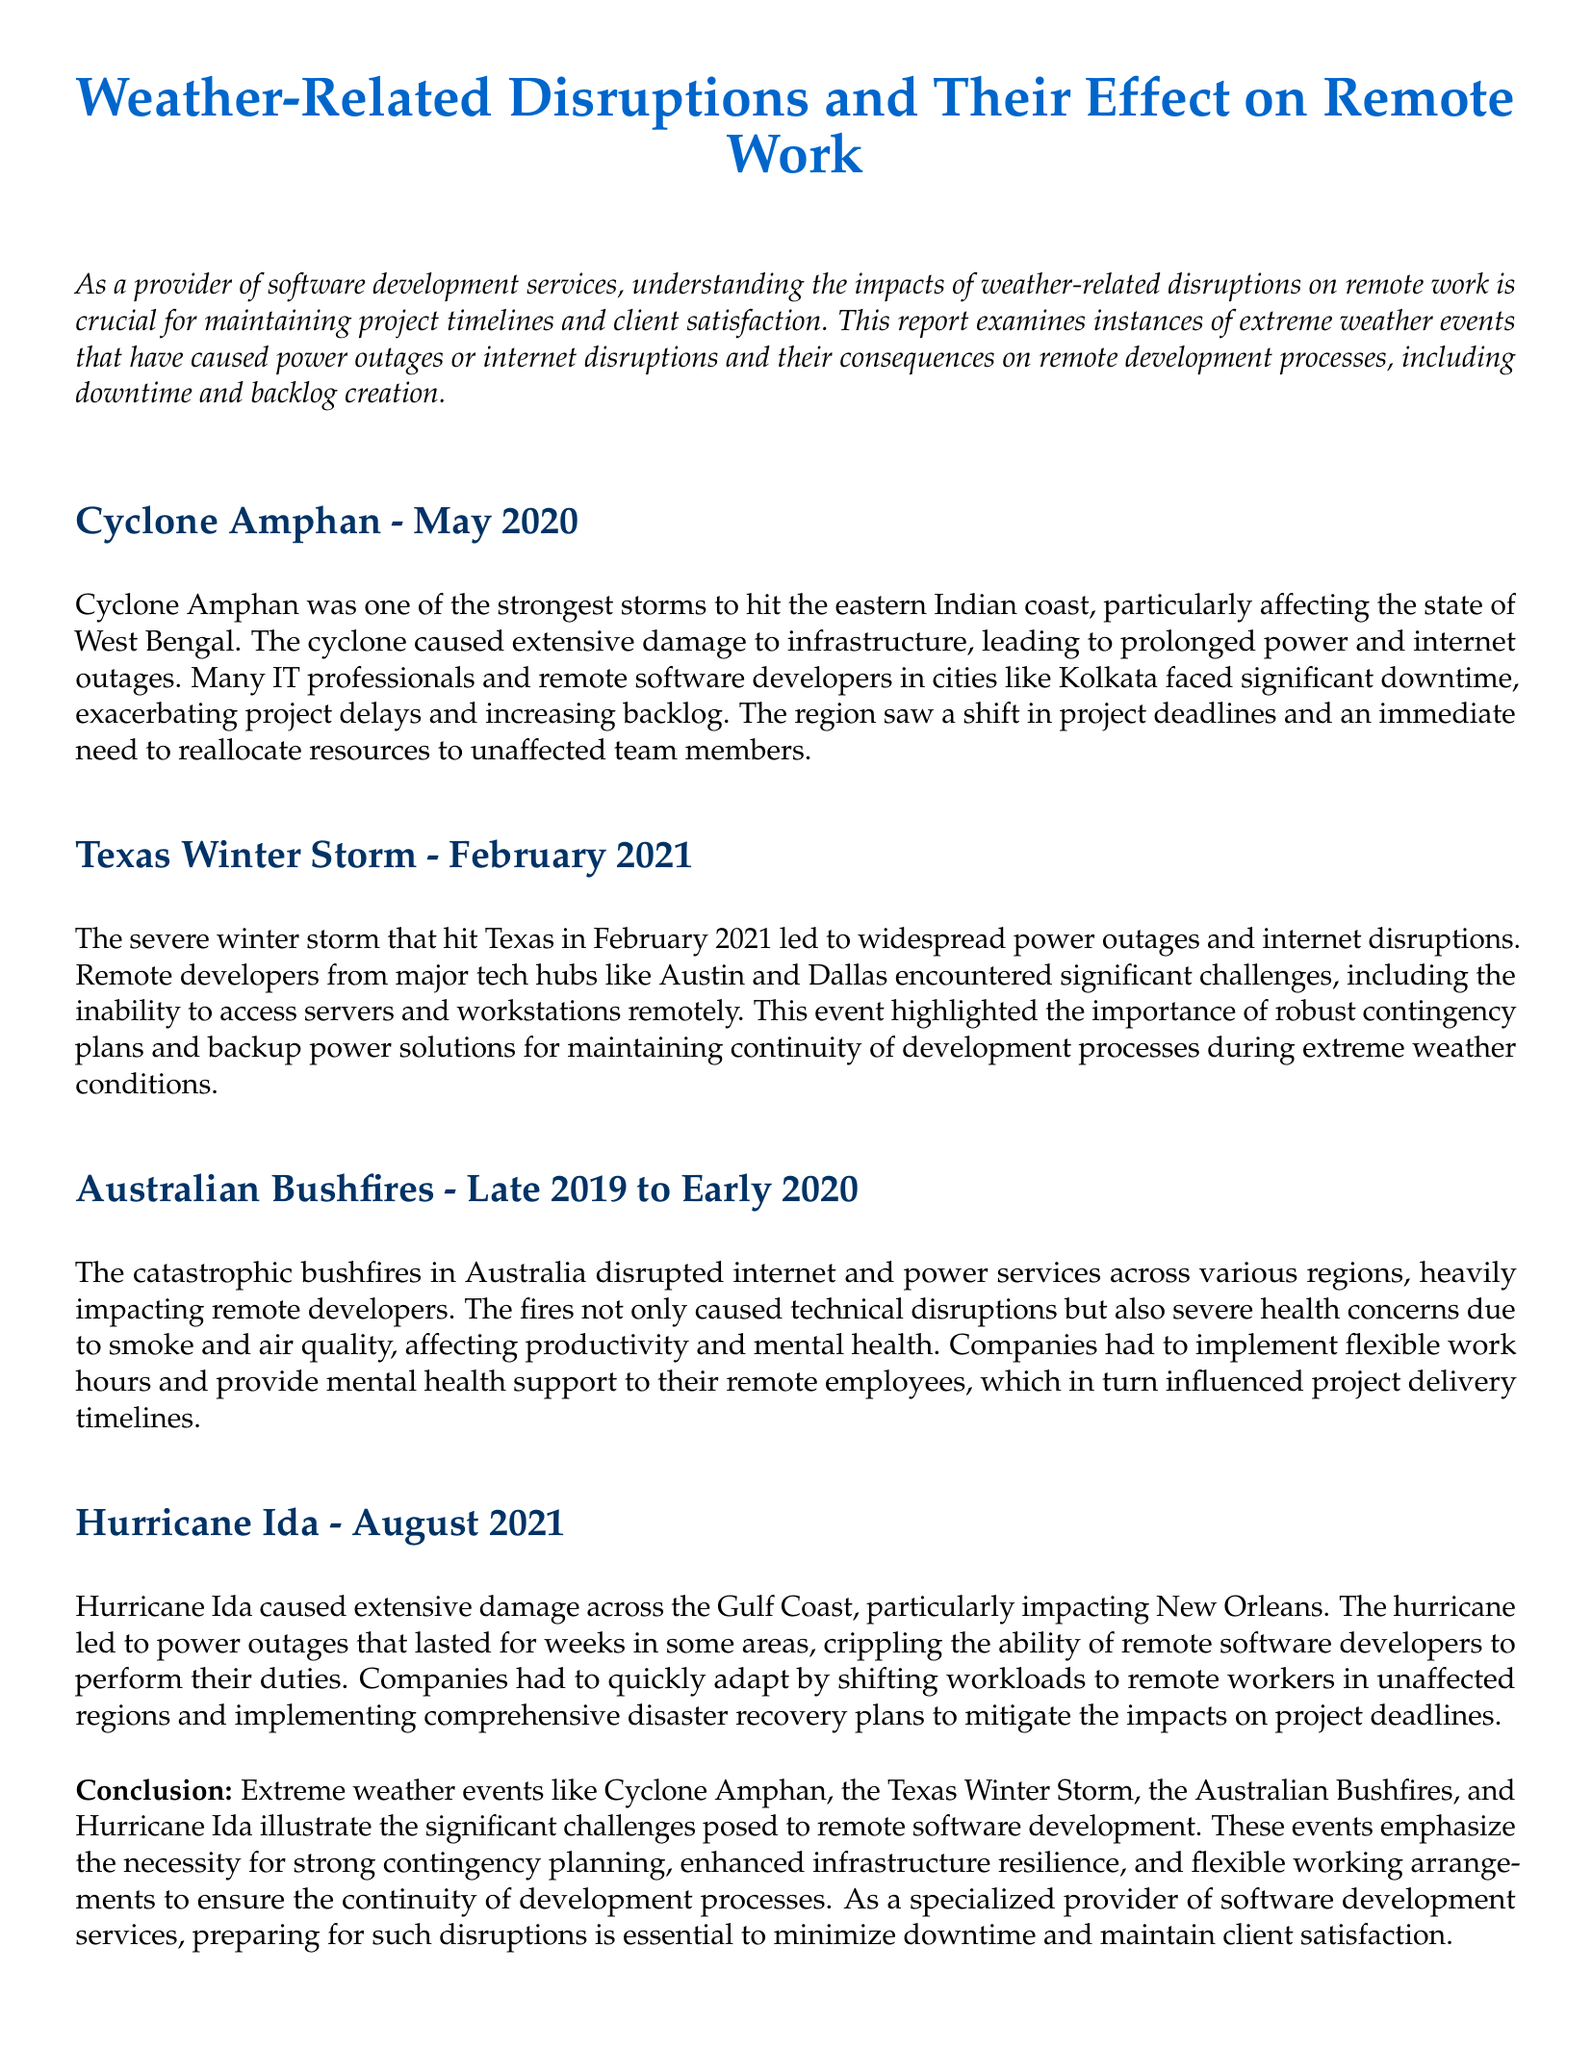What was the name of the cyclone that hit West Bengal in May 2020? The report states that Cyclone Amphan was the significant storm that affected West Bengal in May 2020.
Answer: Cyclone Amphan Which state in India was primarily affected by Cyclone Amphan? The document explicitly mentions that the cyclone primarily impacted the state of West Bengal.
Answer: West Bengal What month and year did the Texas Winter Storm occur? According to the report, the Texas Winter Storm occurred in February 2021.
Answer: February 2021 What consequence did the Australian Bushfires have on remote developers? The bushfires disrupted internet and power services, which affected remote developers' productivity and mental health.
Answer: Disrupted internet and power services How did companies adapt after Hurricane Ida? The document notes that companies shifted workloads to remote workers in unaffected regions and implemented disaster recovery plans.
Answer: Shifted workloads and implemented disaster recovery plans Which event highlighted the importance of contingency plans for remote developers? The Texas Winter Storm is specifically mentioned as an event that highlighted the necessity for robust contingency plans.
Answer: Texas Winter Storm What effect did Cyclone Amphan have on project deadlines? The report indicates that there was a shift in project deadlines due to the cyclone causing downtime for remote developers.
Answer: Shift in project deadlines What type of support did companies provide to remote employees during the Australian Bushfires? Companies had to implement mental health support alongside flexible work hours for their remote employees.
Answer: Mental health support How long did power outages last for some areas after Hurricane Ida? The document states that some areas faced power outages that lasted for weeks after Hurricane Ida.
Answer: Weeks 